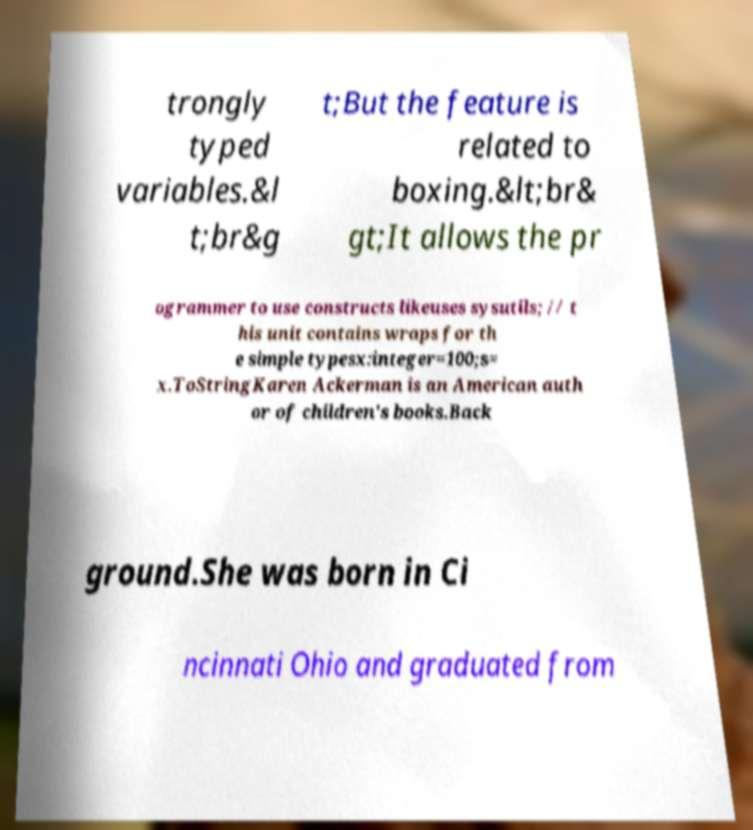Please read and relay the text visible in this image. What does it say? trongly typed variables.&l t;br&g t;But the feature is related to boxing.&lt;br& gt;It allows the pr ogrammer to use constructs likeuses sysutils; // t his unit contains wraps for th e simple typesx:integer=100;s= x.ToStringKaren Ackerman is an American auth or of children's books.Back ground.She was born in Ci ncinnati Ohio and graduated from 